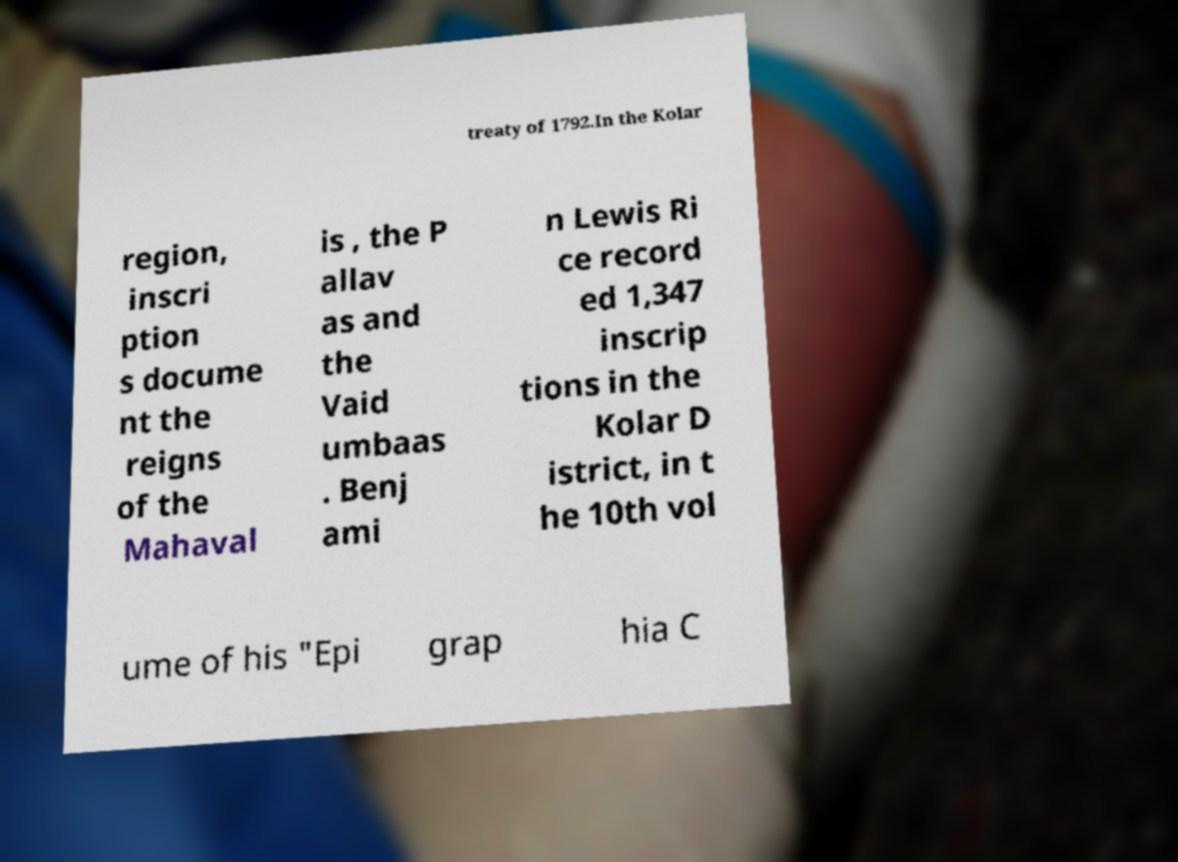Could you extract and type out the text from this image? treaty of 1792.In the Kolar region, inscri ption s docume nt the reigns of the Mahaval is , the P allav as and the Vaid umbaas . Benj ami n Lewis Ri ce record ed 1,347 inscrip tions in the Kolar D istrict, in t he 10th vol ume of his "Epi grap hia C 